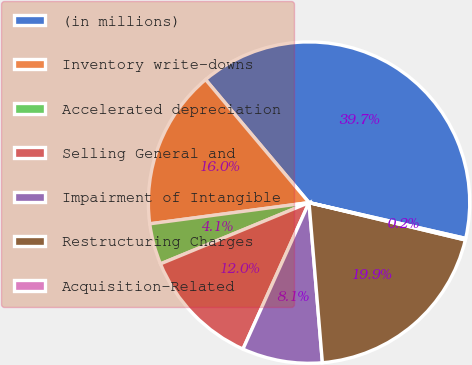<chart> <loc_0><loc_0><loc_500><loc_500><pie_chart><fcel>(in millions)<fcel>Inventory write-downs<fcel>Accelerated depreciation<fcel>Selling General and<fcel>Impairment of Intangible<fcel>Restructuring Charges<fcel>Acquisition-Related<nl><fcel>39.71%<fcel>15.98%<fcel>4.12%<fcel>12.03%<fcel>8.07%<fcel>19.94%<fcel>0.16%<nl></chart> 